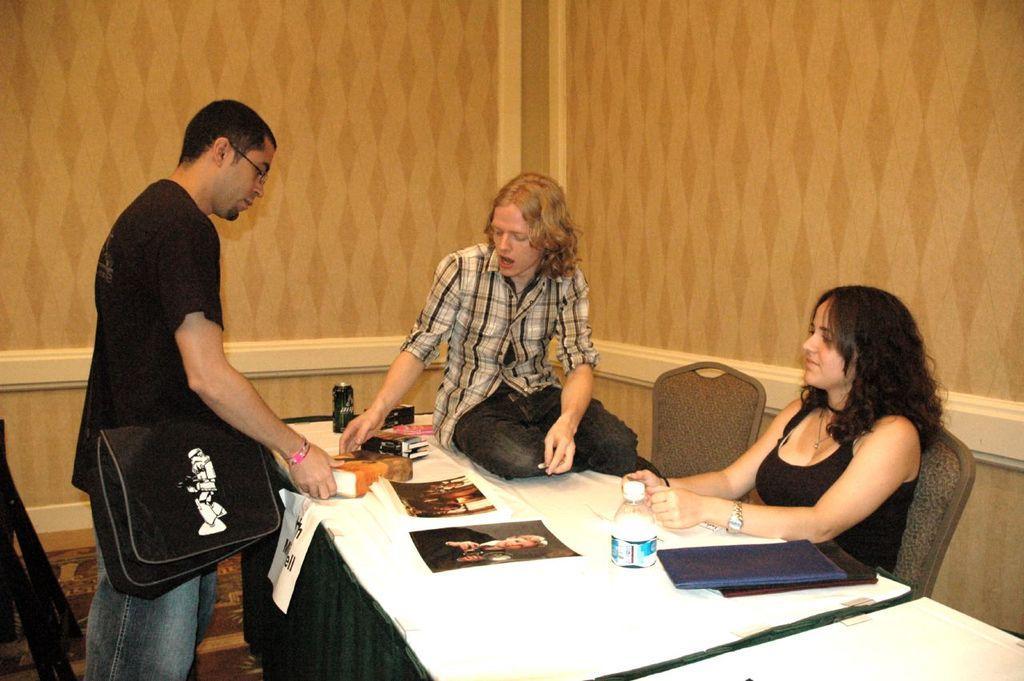How would you summarize this image in a sentence or two? In this picture there is a man wearing a black and a black bag is standing. In the middle,there is a man wearing a black and white checks shirt is sitting on the table. To the right there is a woman wearing a black top and a watch on her wrist is sitting on the chair. There is a bottle on the table. There is a photograph of a woman on the table. There is a coke tin on the table. There is a book on the table. There are some files on the table. There is a green cloth. 